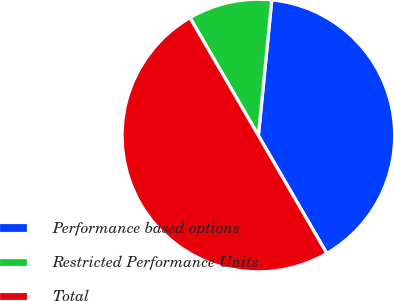<chart> <loc_0><loc_0><loc_500><loc_500><pie_chart><fcel>Performance based options<fcel>Restricted Performance Units<fcel>Total<nl><fcel>40.06%<fcel>9.94%<fcel>50.0%<nl></chart> 